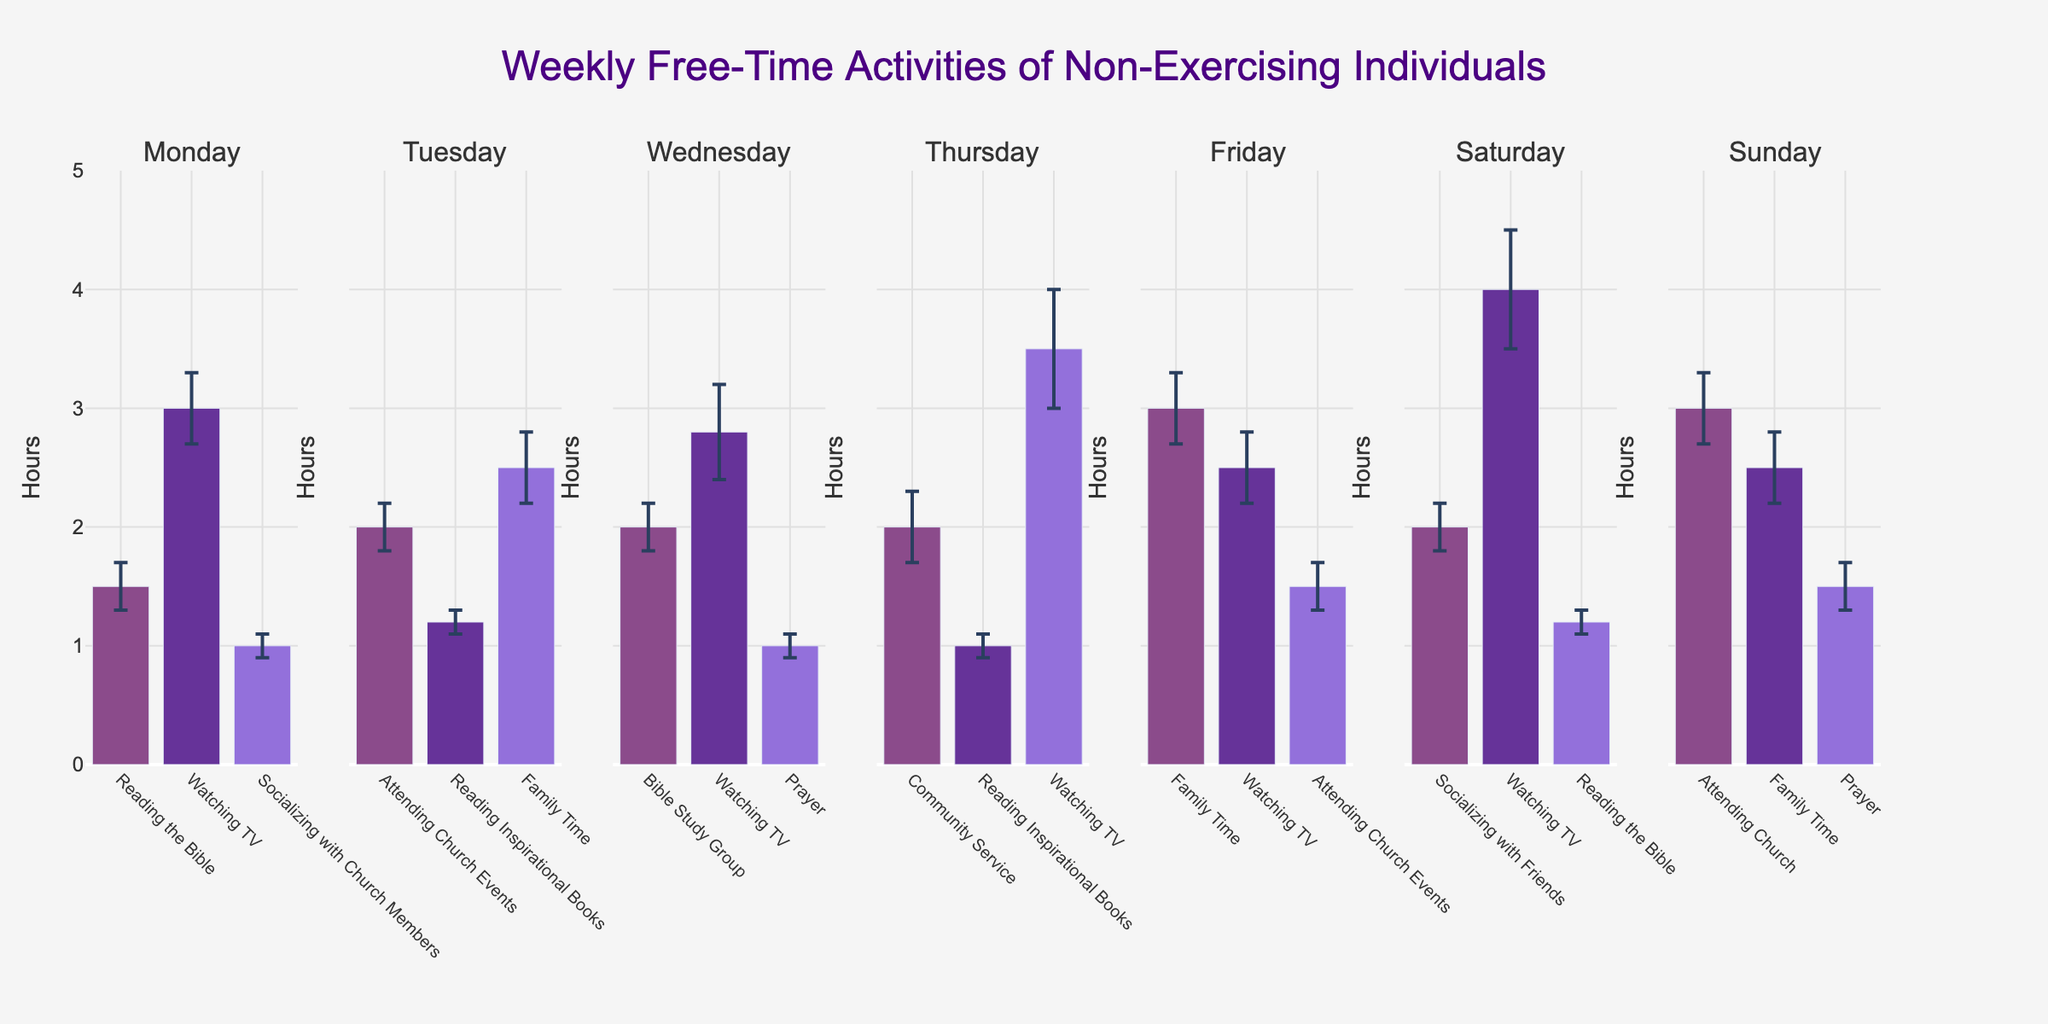What is the title of the figure? The title is displayed at the top center of the figure. It reads "Weekly Free-Time Activities of Non-Exercising Individuals."
Answer: Weekly Free-Time Activities of Non-Exercising Individuals On which day is the most time spent watching TV? By scanning through each subplot representing different days, the bar for 'Watching TV' is the highest on Saturday.
Answer: Saturday How many hours are dedicated to prayer on Sunday? The bar representing 'Prayer' on Sunday shows the height for hours, and its value is approximately 1.5 hours.
Answer: 1.5 hours Which activity has the smallest error bar? Comparing the length of all the error bars on each subplot, 'Socializing with Church Members' on Monday has the smallest error bar.
Answer: Socializing with Church Members Which day has the highest total hours spent on activities? Summing up the heights of all bars for each day, Saturday (Reading the Bible: 1.2, Watching TV: 4.0, Socializing with Friends: 2.0) has the highest total of 7.2 hours.
Answer: Saturday What activity is most commonly engaged in throughout the week? The activity with appearances across the most subplots is considered. 'Watching TV' appears on Monday, Wednesday, Thursday, Friday, and Saturday.
Answer: Watching TV How much time is spent on attending church events throughout the week? Sum the hours for 'Attending Church Events' on Tuesday (2.0 hours) and Friday (1.5 hours), giving a total of 3.5 hours.
Answer: 3.5 hours Which day has the least diverse range of activities? Comparing the number of unique activities each day, Monday has the least diverse range with only 3 activities (Reading the Bible, Watching TV, Socializing with Church Members).
Answer: Monday 